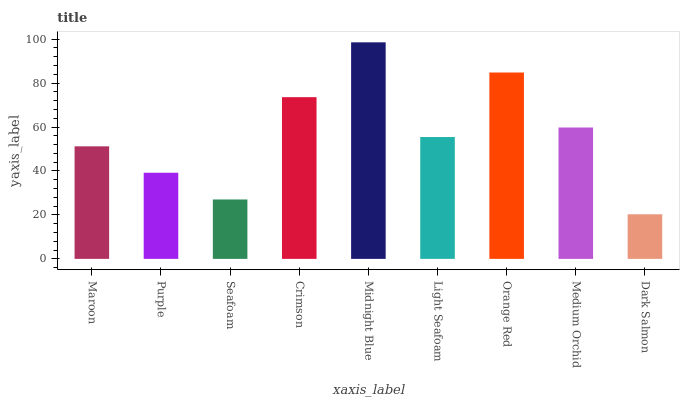Is Purple the minimum?
Answer yes or no. No. Is Purple the maximum?
Answer yes or no. No. Is Maroon greater than Purple?
Answer yes or no. Yes. Is Purple less than Maroon?
Answer yes or no. Yes. Is Purple greater than Maroon?
Answer yes or no. No. Is Maroon less than Purple?
Answer yes or no. No. Is Light Seafoam the high median?
Answer yes or no. Yes. Is Light Seafoam the low median?
Answer yes or no. Yes. Is Maroon the high median?
Answer yes or no. No. Is Purple the low median?
Answer yes or no. No. 